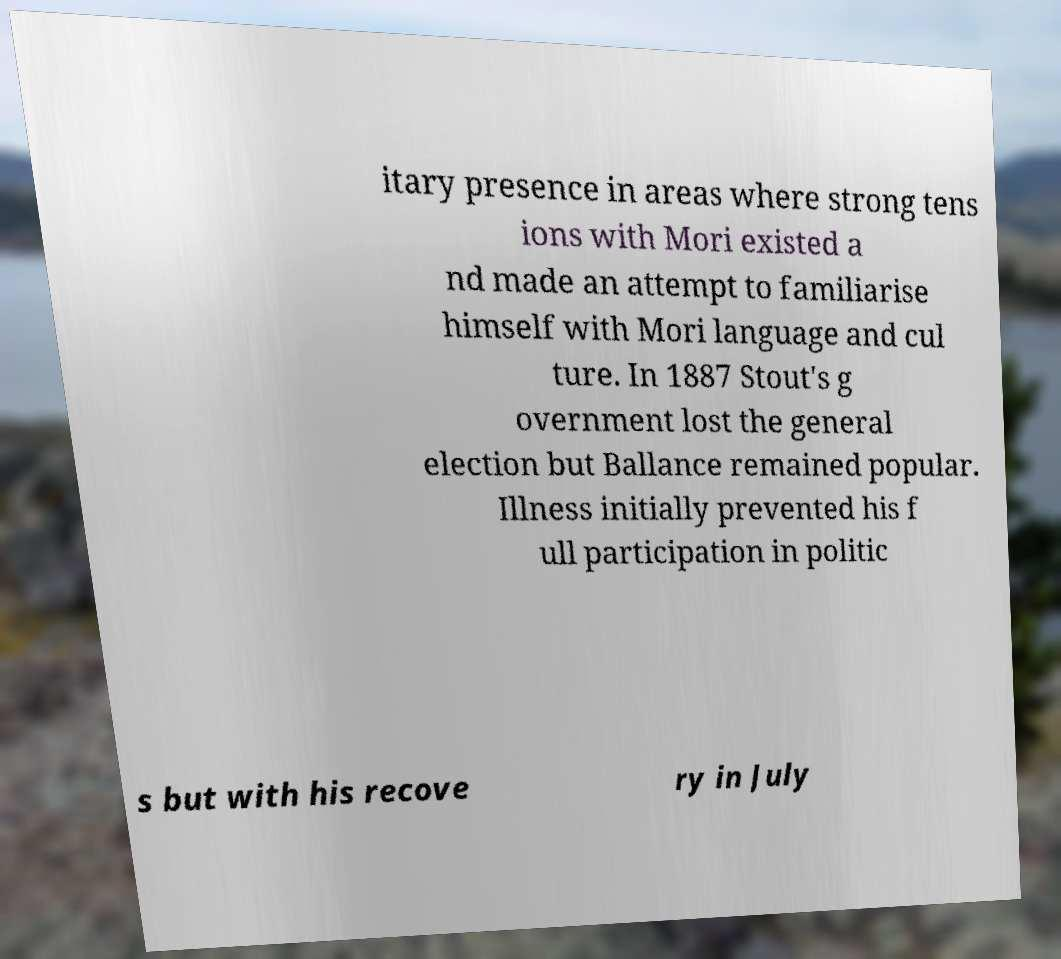Please read and relay the text visible in this image. What does it say? itary presence in areas where strong tens ions with Mori existed a nd made an attempt to familiarise himself with Mori language and cul ture. In 1887 Stout's g overnment lost the general election but Ballance remained popular. Illness initially prevented his f ull participation in politic s but with his recove ry in July 